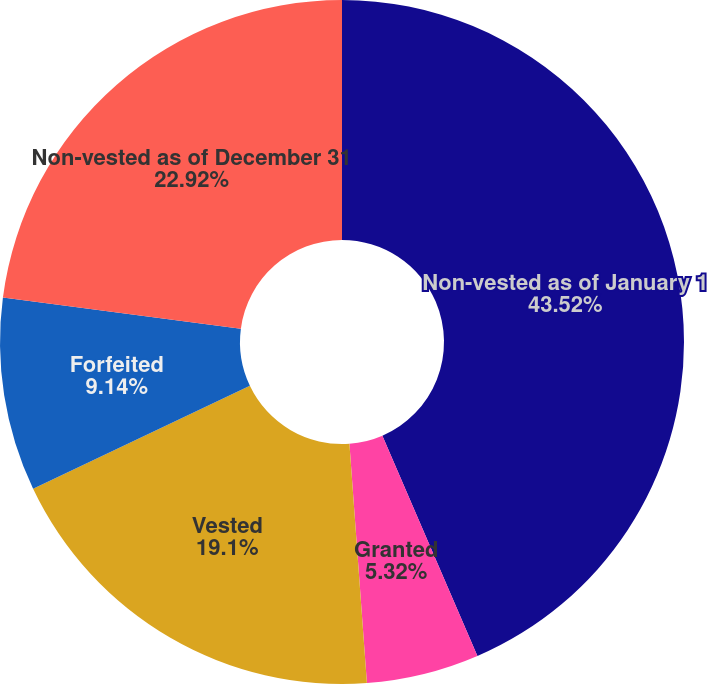Convert chart to OTSL. <chart><loc_0><loc_0><loc_500><loc_500><pie_chart><fcel>Non-vested as of January 1<fcel>Granted<fcel>Vested<fcel>Forfeited<fcel>Non-vested as of December 31<nl><fcel>43.52%<fcel>5.32%<fcel>19.1%<fcel>9.14%<fcel>22.92%<nl></chart> 